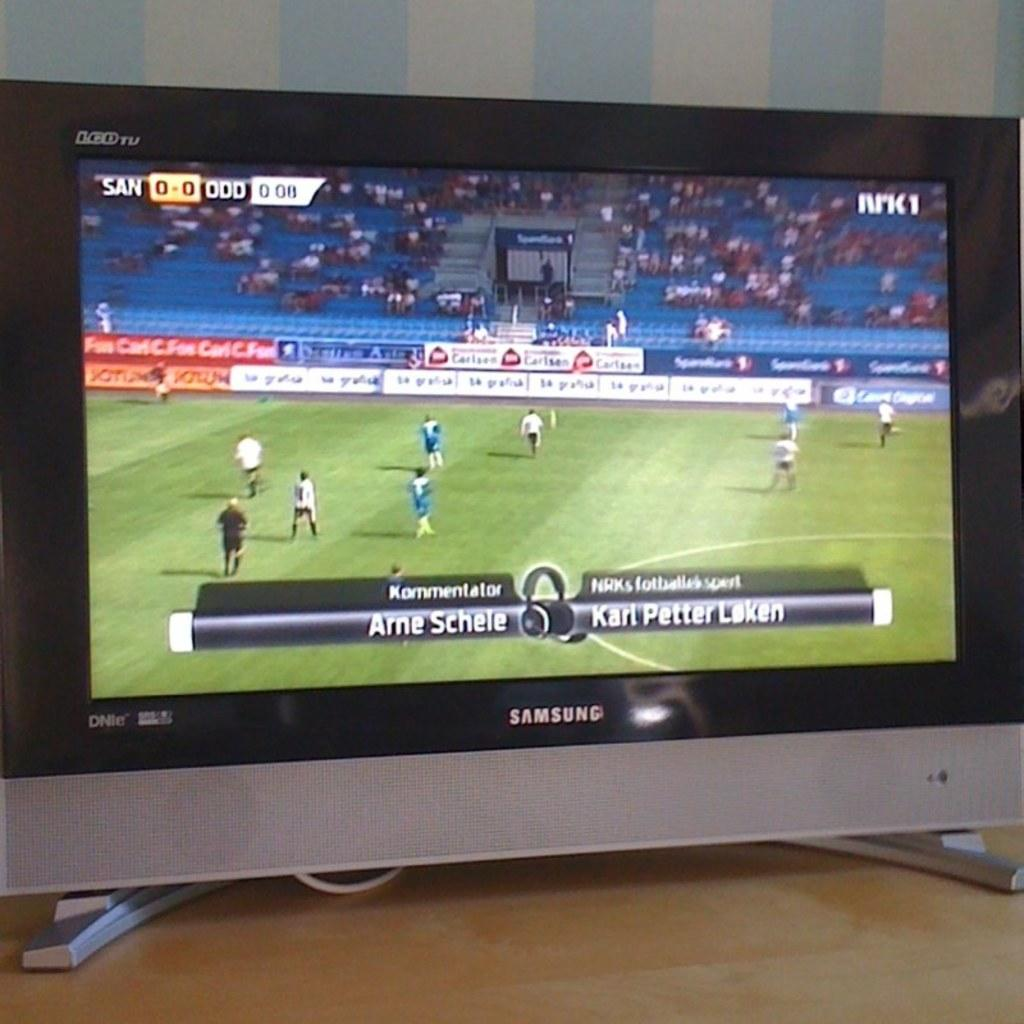<image>
Relay a brief, clear account of the picture shown. A Samsung television shows a soccer match on the screen. 